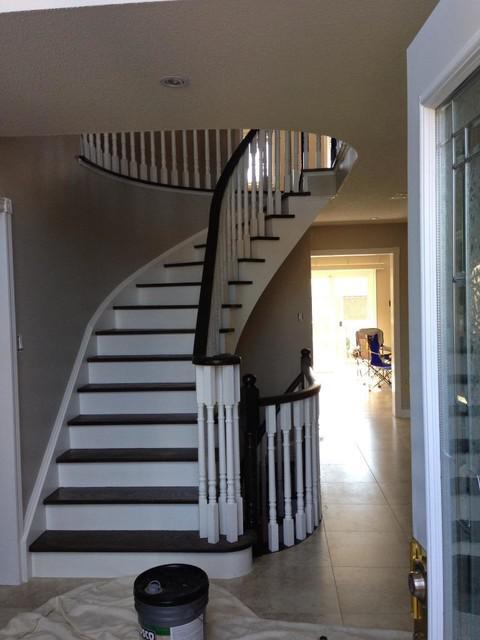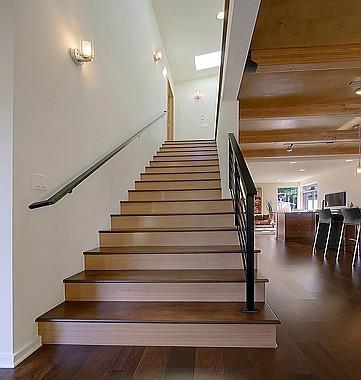The first image is the image on the left, the second image is the image on the right. Assess this claim about the two images: "One image shows a curving staircase with black steps and handrails and white spindles that ascends to a second story.". Correct or not? Answer yes or no. Yes. The first image is the image on the left, the second image is the image on the right. Considering the images on both sides, is "Some stairs are curved." valid? Answer yes or no. Yes. 